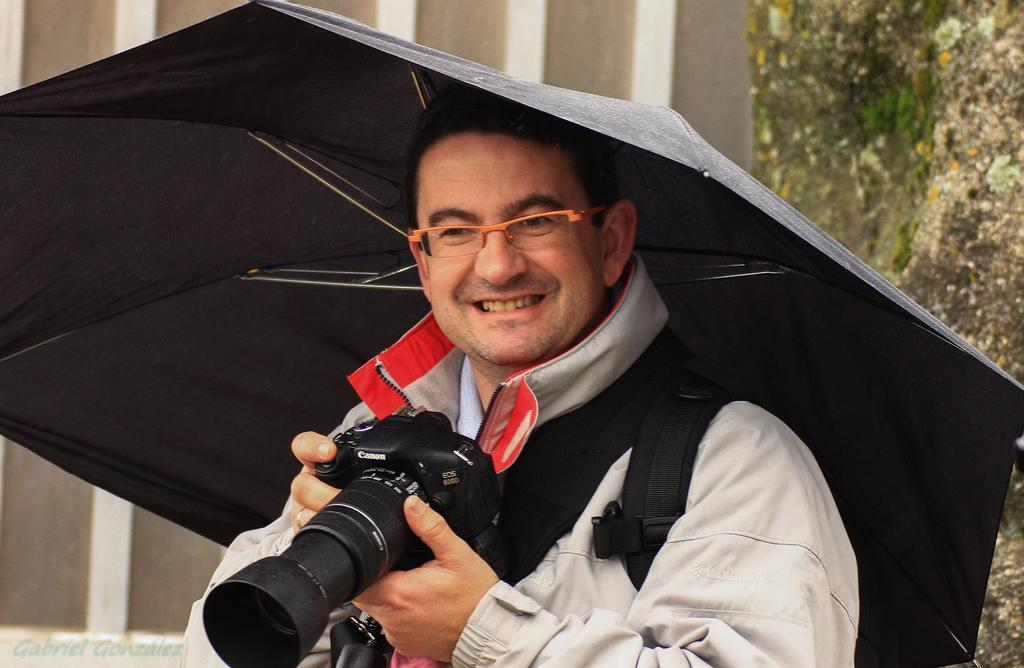What is the main subject of the picture? The main subject of the picture is a man. What is the man doing in the picture? The man is standing and holding a camera in his hands. What is the man's facial expression in the picture? The man is smiling in the picture. What object is the man holding in addition to the camera? The man is holding an umbrella in the picture. What type of winter clothing is the man wearing in the picture? There is no mention of winter clothing in the image, as the facts provided do not indicate any specific season or weather conditions. 